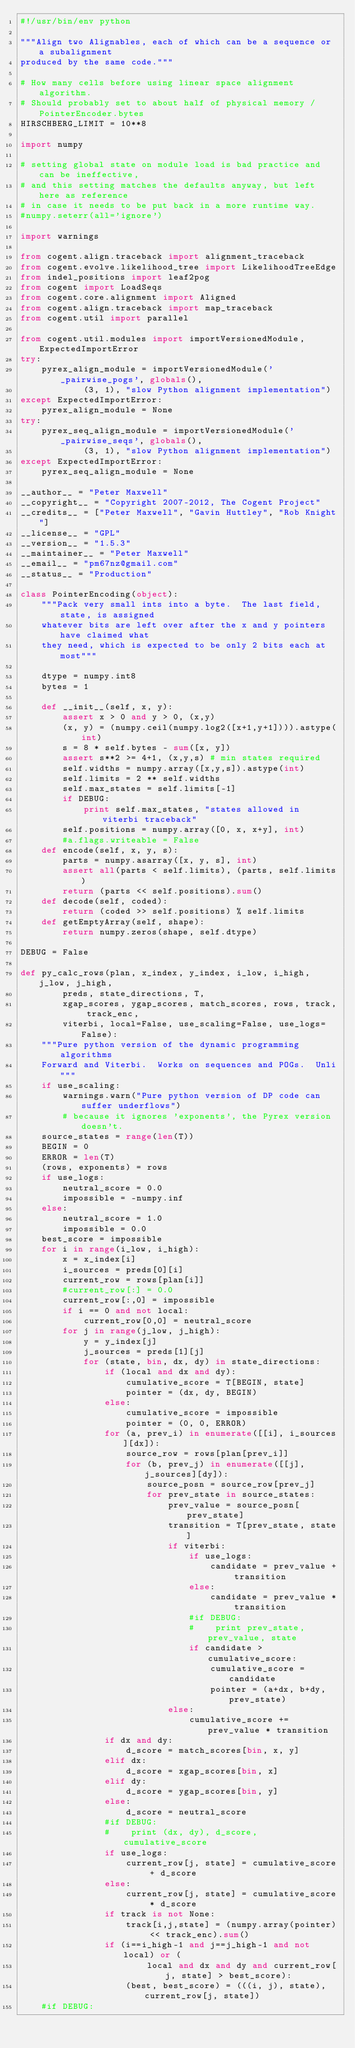<code> <loc_0><loc_0><loc_500><loc_500><_Python_>#!/usr/bin/env python

"""Align two Alignables, each of which can be a sequence or a subalignment
produced by the same code."""

# How many cells before using linear space alignment algorithm.
# Should probably set to about half of physical memory / PointerEncoder.bytes
HIRSCHBERG_LIMIT = 10**8

import numpy

# setting global state on module load is bad practice and can be ineffective,
# and this setting matches the defaults anyway, but left here as reference 
# in case it needs to be put back in a more runtime way.
#numpy.seterr(all='ignore')

import warnings

from cogent.align.traceback import alignment_traceback
from cogent.evolve.likelihood_tree import LikelihoodTreeEdge
from indel_positions import leaf2pog
from cogent import LoadSeqs
from cogent.core.alignment import Aligned
from cogent.align.traceback import map_traceback
from cogent.util import parallel

from cogent.util.modules import importVersionedModule, ExpectedImportError
try:
    pyrex_align_module = importVersionedModule('_pairwise_pogs', globals(),
            (3, 1), "slow Python alignment implementation")
except ExpectedImportError:
    pyrex_align_module = None
try:
    pyrex_seq_align_module = importVersionedModule('_pairwise_seqs', globals(),
            (3, 1), "slow Python alignment implementation")
except ExpectedImportError:
    pyrex_seq_align_module = None

__author__ = "Peter Maxwell"
__copyright__ = "Copyright 2007-2012, The Cogent Project"
__credits__ = ["Peter Maxwell", "Gavin Huttley", "Rob Knight"]
__license__ = "GPL"
__version__ = "1.5.3"
__maintainer__ = "Peter Maxwell"
__email__ = "pm67nz@gmail.com"
__status__ = "Production"

class PointerEncoding(object):
    """Pack very small ints into a byte.  The last field, state, is assigned
    whatever bits are left over after the x and y pointers have claimed what 
    they need, which is expected to be only 2 bits each at most"""
    
    dtype = numpy.int8
    bytes = 1

    def __init__(self, x, y):
        assert x > 0 and y > 0, (x,y)
        (x, y) = (numpy.ceil(numpy.log2([x+1,y+1]))).astype(int)
        s = 8 * self.bytes - sum([x, y])
        assert s**2 >= 4+1, (x,y,s) # min states required
        self.widths = numpy.array([x,y,s]).astype(int)
        self.limits = 2 ** self.widths
        self.max_states = self.limits[-1]
        if DEBUG:
            print self.max_states, "states allowed in viterbi traceback"
        self.positions = numpy.array([0, x, x+y], int)
        #a.flags.writeable = False
    def encode(self, x, y, s):
        parts = numpy.asarray([x, y, s], int)
        assert all(parts < self.limits), (parts, self.limits)
        return (parts << self.positions).sum()
    def decode(self, coded):
        return (coded >> self.positions) % self.limits
    def getEmptyArray(self, shape):
        return numpy.zeros(shape, self.dtype)
    
DEBUG = False

def py_calc_rows(plan, x_index, y_index, i_low, i_high, j_low, j_high,
        preds, state_directions, T,
        xgap_scores, ygap_scores, match_scores, rows, track, track_enc, 
        viterbi, local=False, use_scaling=False, use_logs=False):
    """Pure python version of the dynamic programming algorithms
    Forward and Viterbi.  Works on sequences and POGs.  Unli"""
    if use_scaling:
        warnings.warn("Pure python version of DP code can suffer underflows")
        # because it ignores 'exponents', the Pyrex version doesn't.
    source_states = range(len(T))
    BEGIN = 0
    ERROR = len(T)
    (rows, exponents) = rows
    if use_logs:
        neutral_score = 0.0
        impossible = -numpy.inf
    else:
        neutral_score = 1.0
        impossible = 0.0
    best_score = impossible
    for i in range(i_low, i_high):
        x = x_index[i]
        i_sources = preds[0][i]
        current_row = rows[plan[i]]
        #current_row[:] = 0.0
        current_row[:,0] = impossible
        if i == 0 and not local:
            current_row[0,0] = neutral_score
        for j in range(j_low, j_high):
            y = y_index[j]
            j_sources = preds[1][j]
            for (state, bin, dx, dy) in state_directions:
                if (local and dx and dy):
                    cumulative_score = T[BEGIN, state]
                    pointer = (dx, dy, BEGIN)
                else:
                    cumulative_score = impossible
                    pointer = (0, 0, ERROR)
                for (a, prev_i) in enumerate([[i], i_sources][dx]):
                    source_row = rows[plan[prev_i]]
                    for (b, prev_j) in enumerate([[j], j_sources][dy]):
                        source_posn = source_row[prev_j]
                        for prev_state in source_states:
                            prev_value = source_posn[prev_state]
                            transition = T[prev_state, state]
                            if viterbi:
                                if use_logs:
                                    candidate = prev_value + transition
                                else:
                                    candidate = prev_value * transition
                                #if DEBUG:
                                #    print prev_state, prev_value, state
                                if candidate > cumulative_score:
                                    cumulative_score = candidate
                                    pointer = (a+dx, b+dy, prev_state)
                            else:
                                cumulative_score += prev_value * transition
                if dx and dy:
                    d_score = match_scores[bin, x, y]
                elif dx:
                    d_score = xgap_scores[bin, x]
                elif dy:
                    d_score = ygap_scores[bin, y]
                else:
                    d_score = neutral_score
                #if DEBUG:
                #    print (dx, dy), d_score, cumulative_score
                if use_logs:
                    current_row[j, state] = cumulative_score + d_score
                else:
                    current_row[j, state] = cumulative_score * d_score
                if track is not None:
                    track[i,j,state] = (numpy.array(pointer) << track_enc).sum()
                if (i==i_high-1 and j==j_high-1 and not local) or (
                        local and dx and dy and current_row[j, state] > best_score):
                    (best, best_score) = (((i, j), state), current_row[j, state])
    #if DEBUG:</code> 